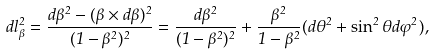<formula> <loc_0><loc_0><loc_500><loc_500>d l _ { \beta } ^ { 2 } = { \frac { d { \beta } ^ { 2 } - ( { \beta } \times d { \beta } ) ^ { 2 } } { ( 1 - \beta ^ { 2 } ) ^ { 2 } } } = { \frac { d \beta ^ { 2 } } { ( 1 - \beta ^ { 2 } ) ^ { 2 } } } + { \frac { \beta ^ { 2 } } { 1 - \beta ^ { 2 } } } ( d \theta ^ { 2 } + \sin ^ { 2 } \theta d \varphi ^ { 2 } ) ,</formula> 